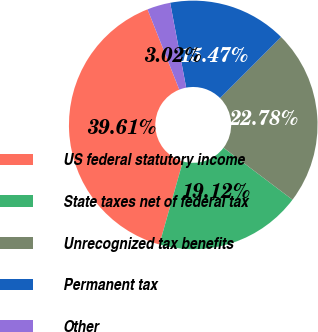<chart> <loc_0><loc_0><loc_500><loc_500><pie_chart><fcel>US federal statutory income<fcel>State taxes net of federal tax<fcel>Unrecognized tax benefits<fcel>Permanent tax<fcel>Other<nl><fcel>39.61%<fcel>19.12%<fcel>22.78%<fcel>15.47%<fcel>3.02%<nl></chart> 